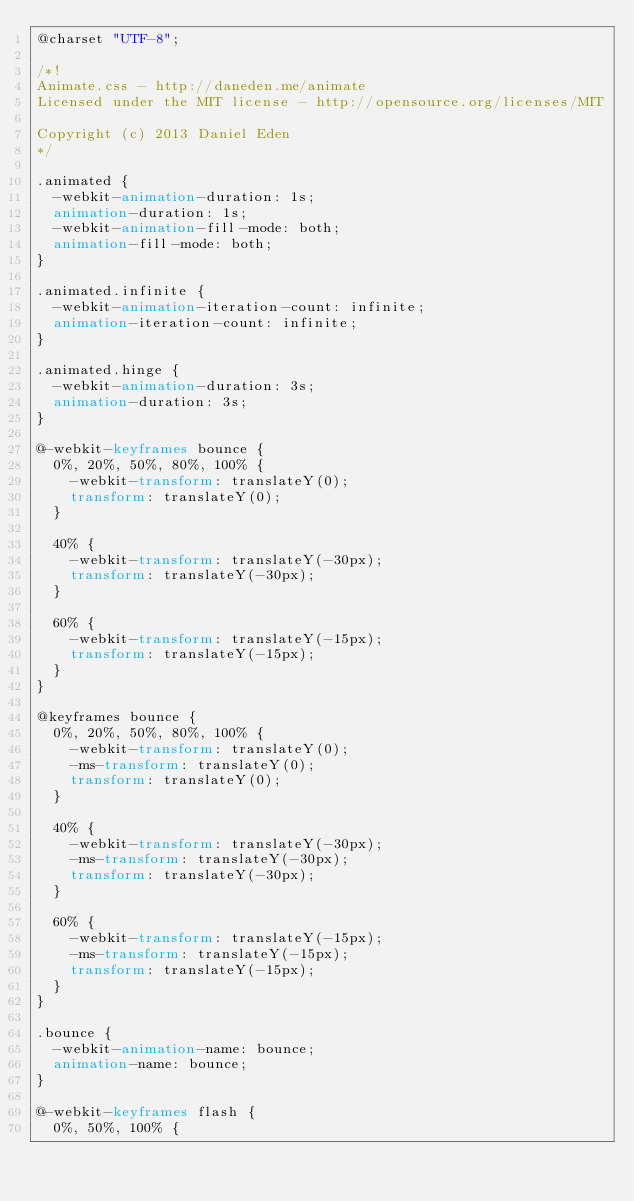Convert code to text. <code><loc_0><loc_0><loc_500><loc_500><_CSS_>@charset "UTF-8";

/*!
Animate.css - http://daneden.me/animate
Licensed under the MIT license - http://opensource.org/licenses/MIT

Copyright (c) 2013 Daniel Eden
*/

.animated {
  -webkit-animation-duration: 1s;
  animation-duration: 1s;
  -webkit-animation-fill-mode: both;
  animation-fill-mode: both;
}

.animated.infinite {
  -webkit-animation-iteration-count: infinite;
  animation-iteration-count: infinite;
}

.animated.hinge {
  -webkit-animation-duration: 3s;
  animation-duration: 3s;
}

@-webkit-keyframes bounce {
  0%, 20%, 50%, 80%, 100% {
    -webkit-transform: translateY(0);
    transform: translateY(0);
  }

  40% {
    -webkit-transform: translateY(-30px);
    transform: translateY(-30px);
  }

  60% {
    -webkit-transform: translateY(-15px);
    transform: translateY(-15px);
  }
}

@keyframes bounce {
  0%, 20%, 50%, 80%, 100% {
    -webkit-transform: translateY(0);
    -ms-transform: translateY(0);
    transform: translateY(0);
  }

  40% {
    -webkit-transform: translateY(-30px);
    -ms-transform: translateY(-30px);
    transform: translateY(-30px);
  }

  60% {
    -webkit-transform: translateY(-15px);
    -ms-transform: translateY(-15px);
    transform: translateY(-15px);
  }
}

.bounce {
  -webkit-animation-name: bounce;
  animation-name: bounce;
}

@-webkit-keyframes flash {
  0%, 50%, 100% {</code> 